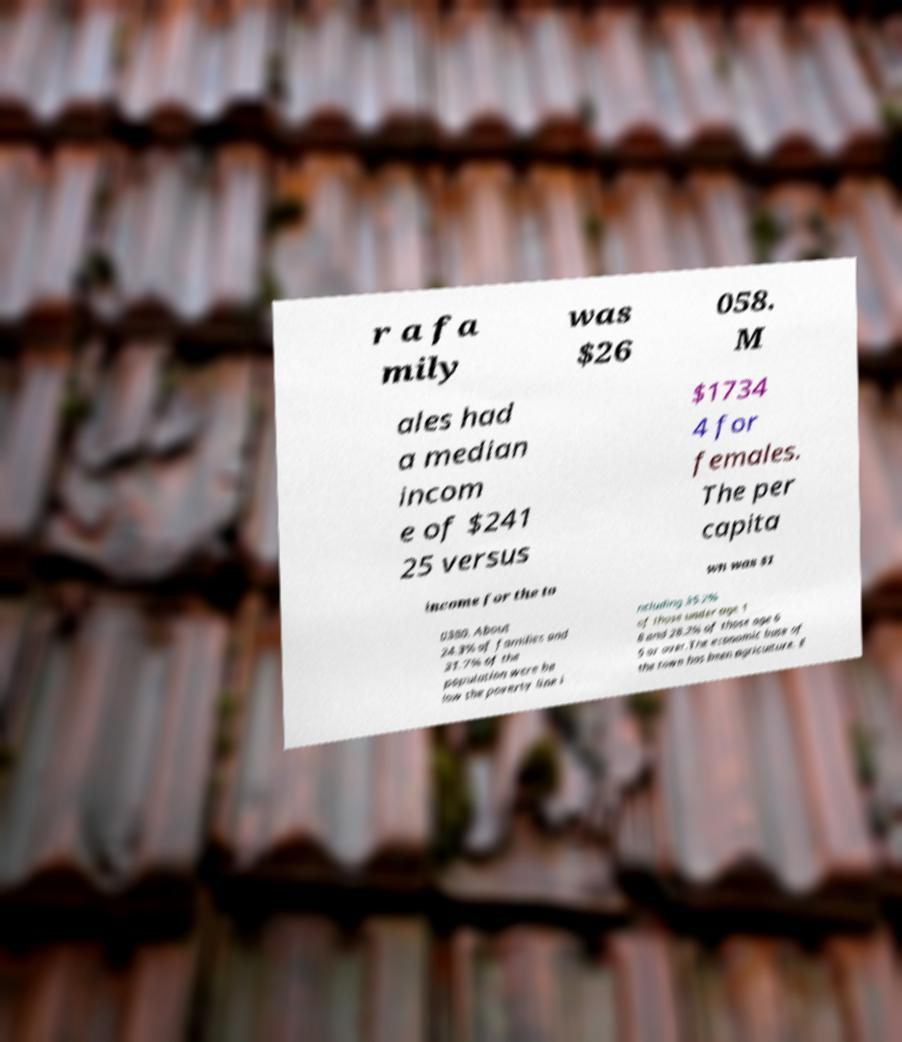There's text embedded in this image that I need extracted. Can you transcribe it verbatim? r a fa mily was $26 058. M ales had a median incom e of $241 25 versus $1734 4 for females. The per capita income for the to wn was $1 0380. About 24.3% of families and 31.7% of the population were be low the poverty line i ncluding 35.2% of those under age 1 8 and 28.2% of those age 6 5 or over.The economic base of the town has been agriculture. E 